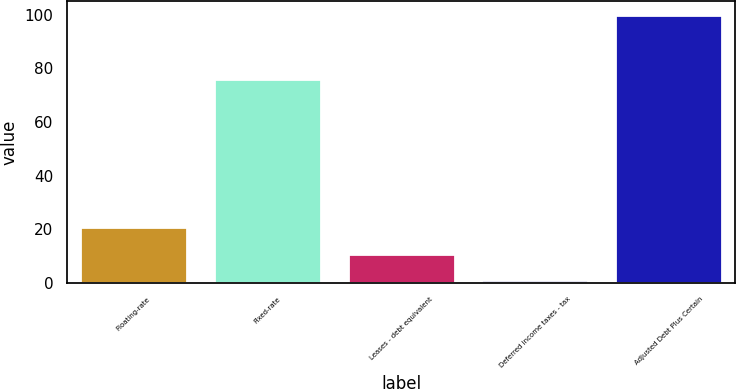<chart> <loc_0><loc_0><loc_500><loc_500><bar_chart><fcel>Floating-rate<fcel>Fixed-rate<fcel>Leases - debt equivalent<fcel>Deferred income taxes - tax<fcel>Adjusted Debt Plus Certain<nl><fcel>20.8<fcel>76<fcel>10.9<fcel>1<fcel>100<nl></chart> 